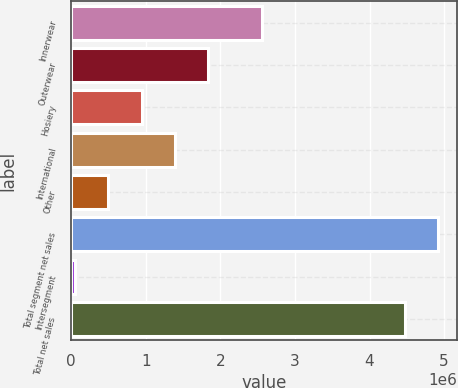Convert chart to OTSL. <chart><loc_0><loc_0><loc_500><loc_500><bar_chart><fcel>Innerwear<fcel>Outerwear<fcel>Hosiery<fcel>International<fcel>Other<fcel>Total segment net sales<fcel>Intersegment<fcel>Total net sales<nl><fcel>2.55691e+06<fcel>1.83904e+06<fcel>944137<fcel>1.39159e+06<fcel>496684<fcel>4.92199e+06<fcel>49230<fcel>4.47454e+06<nl></chart> 